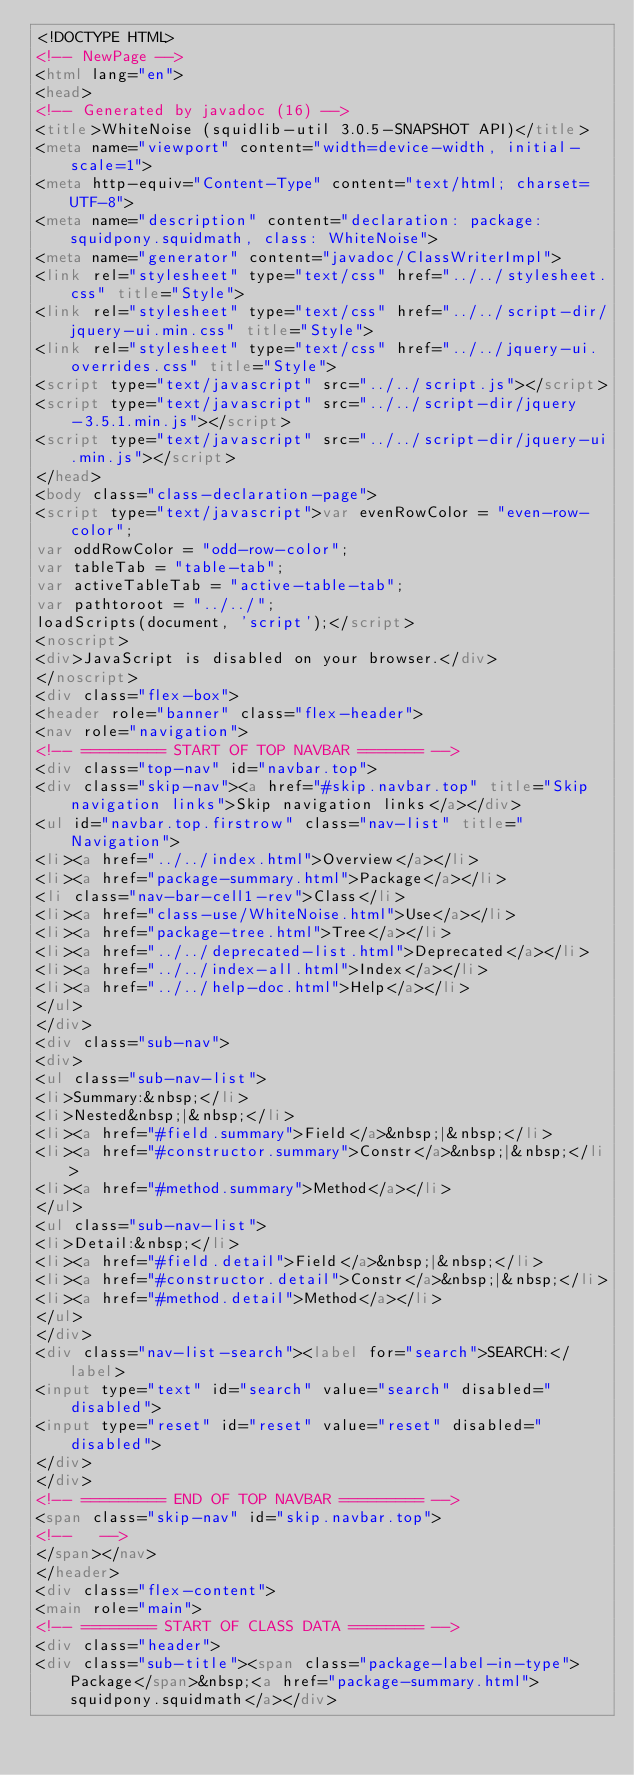<code> <loc_0><loc_0><loc_500><loc_500><_HTML_><!DOCTYPE HTML>
<!-- NewPage -->
<html lang="en">
<head>
<!-- Generated by javadoc (16) -->
<title>WhiteNoise (squidlib-util 3.0.5-SNAPSHOT API)</title>
<meta name="viewport" content="width=device-width, initial-scale=1">
<meta http-equiv="Content-Type" content="text/html; charset=UTF-8">
<meta name="description" content="declaration: package: squidpony.squidmath, class: WhiteNoise">
<meta name="generator" content="javadoc/ClassWriterImpl">
<link rel="stylesheet" type="text/css" href="../../stylesheet.css" title="Style">
<link rel="stylesheet" type="text/css" href="../../script-dir/jquery-ui.min.css" title="Style">
<link rel="stylesheet" type="text/css" href="../../jquery-ui.overrides.css" title="Style">
<script type="text/javascript" src="../../script.js"></script>
<script type="text/javascript" src="../../script-dir/jquery-3.5.1.min.js"></script>
<script type="text/javascript" src="../../script-dir/jquery-ui.min.js"></script>
</head>
<body class="class-declaration-page">
<script type="text/javascript">var evenRowColor = "even-row-color";
var oddRowColor = "odd-row-color";
var tableTab = "table-tab";
var activeTableTab = "active-table-tab";
var pathtoroot = "../../";
loadScripts(document, 'script');</script>
<noscript>
<div>JavaScript is disabled on your browser.</div>
</noscript>
<div class="flex-box">
<header role="banner" class="flex-header">
<nav role="navigation">
<!-- ========= START OF TOP NAVBAR ======= -->
<div class="top-nav" id="navbar.top">
<div class="skip-nav"><a href="#skip.navbar.top" title="Skip navigation links">Skip navigation links</a></div>
<ul id="navbar.top.firstrow" class="nav-list" title="Navigation">
<li><a href="../../index.html">Overview</a></li>
<li><a href="package-summary.html">Package</a></li>
<li class="nav-bar-cell1-rev">Class</li>
<li><a href="class-use/WhiteNoise.html">Use</a></li>
<li><a href="package-tree.html">Tree</a></li>
<li><a href="../../deprecated-list.html">Deprecated</a></li>
<li><a href="../../index-all.html">Index</a></li>
<li><a href="../../help-doc.html">Help</a></li>
</ul>
</div>
<div class="sub-nav">
<div>
<ul class="sub-nav-list">
<li>Summary:&nbsp;</li>
<li>Nested&nbsp;|&nbsp;</li>
<li><a href="#field.summary">Field</a>&nbsp;|&nbsp;</li>
<li><a href="#constructor.summary">Constr</a>&nbsp;|&nbsp;</li>
<li><a href="#method.summary">Method</a></li>
</ul>
<ul class="sub-nav-list">
<li>Detail:&nbsp;</li>
<li><a href="#field.detail">Field</a>&nbsp;|&nbsp;</li>
<li><a href="#constructor.detail">Constr</a>&nbsp;|&nbsp;</li>
<li><a href="#method.detail">Method</a></li>
</ul>
</div>
<div class="nav-list-search"><label for="search">SEARCH:</label>
<input type="text" id="search" value="search" disabled="disabled">
<input type="reset" id="reset" value="reset" disabled="disabled">
</div>
</div>
<!-- ========= END OF TOP NAVBAR ========= -->
<span class="skip-nav" id="skip.navbar.top">
<!--   -->
</span></nav>
</header>
<div class="flex-content">
<main role="main">
<!-- ======== START OF CLASS DATA ======== -->
<div class="header">
<div class="sub-title"><span class="package-label-in-type">Package</span>&nbsp;<a href="package-summary.html">squidpony.squidmath</a></div></code> 